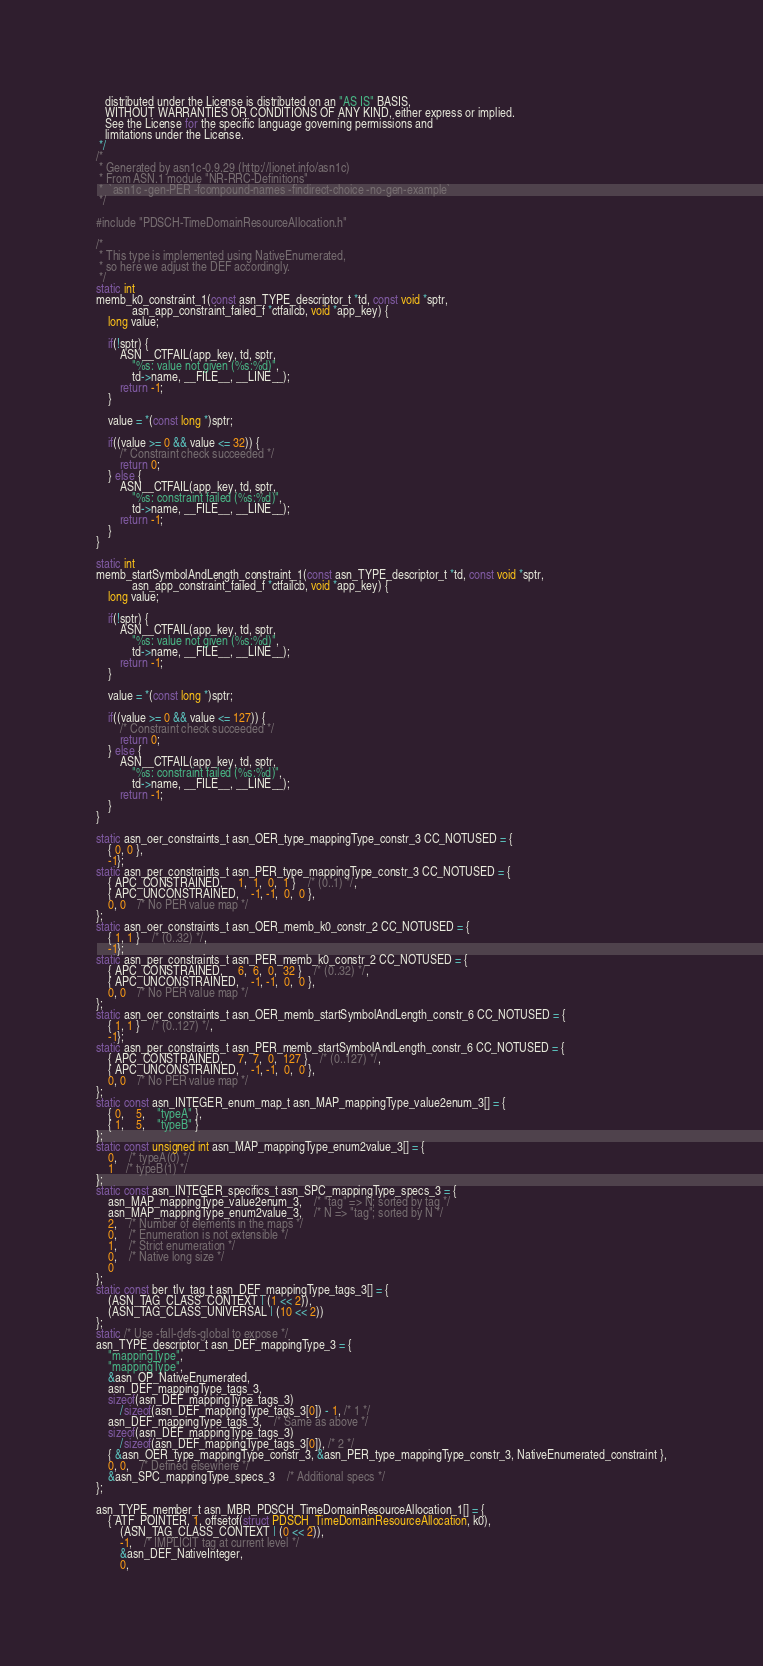<code> <loc_0><loc_0><loc_500><loc_500><_C_>   distributed under the License is distributed on an "AS IS" BASIS,
   WITHOUT WARRANTIES OR CONDITIONS OF ANY KIND, either express or implied.
   See the License for the specific language governing permissions and
   limitations under the License.
 */
/*
 * Generated by asn1c-0.9.29 (http://lionet.info/asn1c)
 * From ASN.1 module "NR-RRC-Definitions"
 * 	`asn1c -gen-PER -fcompound-names -findirect-choice -no-gen-example`
 */

#include "PDSCH-TimeDomainResourceAllocation.h"

/*
 * This type is implemented using NativeEnumerated,
 * so here we adjust the DEF accordingly.
 */
static int
memb_k0_constraint_1(const asn_TYPE_descriptor_t *td, const void *sptr,
			asn_app_constraint_failed_f *ctfailcb, void *app_key) {
	long value;
	
	if(!sptr) {
		ASN__CTFAIL(app_key, td, sptr,
			"%s: value not given (%s:%d)",
			td->name, __FILE__, __LINE__);
		return -1;
	}
	
	value = *(const long *)sptr;
	
	if((value >= 0 && value <= 32)) {
		/* Constraint check succeeded */
		return 0;
	} else {
		ASN__CTFAIL(app_key, td, sptr,
			"%s: constraint failed (%s:%d)",
			td->name, __FILE__, __LINE__);
		return -1;
	}
}

static int
memb_startSymbolAndLength_constraint_1(const asn_TYPE_descriptor_t *td, const void *sptr,
			asn_app_constraint_failed_f *ctfailcb, void *app_key) {
	long value;
	
	if(!sptr) {
		ASN__CTFAIL(app_key, td, sptr,
			"%s: value not given (%s:%d)",
			td->name, __FILE__, __LINE__);
		return -1;
	}
	
	value = *(const long *)sptr;
	
	if((value >= 0 && value <= 127)) {
		/* Constraint check succeeded */
		return 0;
	} else {
		ASN__CTFAIL(app_key, td, sptr,
			"%s: constraint failed (%s:%d)",
			td->name, __FILE__, __LINE__);
		return -1;
	}
}

static asn_oer_constraints_t asn_OER_type_mappingType_constr_3 CC_NOTUSED = {
	{ 0, 0 },
	-1};
static asn_per_constraints_t asn_PER_type_mappingType_constr_3 CC_NOTUSED = {
	{ APC_CONSTRAINED,	 1,  1,  0,  1 }	/* (0..1) */,
	{ APC_UNCONSTRAINED,	-1, -1,  0,  0 },
	0, 0	/* No PER value map */
};
static asn_oer_constraints_t asn_OER_memb_k0_constr_2 CC_NOTUSED = {
	{ 1, 1 }	/* (0..32) */,
	-1};
static asn_per_constraints_t asn_PER_memb_k0_constr_2 CC_NOTUSED = {
	{ APC_CONSTRAINED,	 6,  6,  0,  32 }	/* (0..32) */,
	{ APC_UNCONSTRAINED,	-1, -1,  0,  0 },
	0, 0	/* No PER value map */
};
static asn_oer_constraints_t asn_OER_memb_startSymbolAndLength_constr_6 CC_NOTUSED = {
	{ 1, 1 }	/* (0..127) */,
	-1};
static asn_per_constraints_t asn_PER_memb_startSymbolAndLength_constr_6 CC_NOTUSED = {
	{ APC_CONSTRAINED,	 7,  7,  0,  127 }	/* (0..127) */,
	{ APC_UNCONSTRAINED,	-1, -1,  0,  0 },
	0, 0	/* No PER value map */
};
static const asn_INTEGER_enum_map_t asn_MAP_mappingType_value2enum_3[] = {
	{ 0,	5,	"typeA" },
	{ 1,	5,	"typeB" }
};
static const unsigned int asn_MAP_mappingType_enum2value_3[] = {
	0,	/* typeA(0) */
	1	/* typeB(1) */
};
static const asn_INTEGER_specifics_t asn_SPC_mappingType_specs_3 = {
	asn_MAP_mappingType_value2enum_3,	/* "tag" => N; sorted by tag */
	asn_MAP_mappingType_enum2value_3,	/* N => "tag"; sorted by N */
	2,	/* Number of elements in the maps */
	0,	/* Enumeration is not extensible */
	1,	/* Strict enumeration */
	0,	/* Native long size */
	0
};
static const ber_tlv_tag_t asn_DEF_mappingType_tags_3[] = {
	(ASN_TAG_CLASS_CONTEXT | (1 << 2)),
	(ASN_TAG_CLASS_UNIVERSAL | (10 << 2))
};
static /* Use -fall-defs-global to expose */
asn_TYPE_descriptor_t asn_DEF_mappingType_3 = {
	"mappingType",
	"mappingType",
	&asn_OP_NativeEnumerated,
	asn_DEF_mappingType_tags_3,
	sizeof(asn_DEF_mappingType_tags_3)
		/sizeof(asn_DEF_mappingType_tags_3[0]) - 1, /* 1 */
	asn_DEF_mappingType_tags_3,	/* Same as above */
	sizeof(asn_DEF_mappingType_tags_3)
		/sizeof(asn_DEF_mappingType_tags_3[0]), /* 2 */
	{ &asn_OER_type_mappingType_constr_3, &asn_PER_type_mappingType_constr_3, NativeEnumerated_constraint },
	0, 0,	/* Defined elsewhere */
	&asn_SPC_mappingType_specs_3	/* Additional specs */
};

asn_TYPE_member_t asn_MBR_PDSCH_TimeDomainResourceAllocation_1[] = {
	{ ATF_POINTER, 1, offsetof(struct PDSCH_TimeDomainResourceAllocation, k0),
		(ASN_TAG_CLASS_CONTEXT | (0 << 2)),
		-1,	/* IMPLICIT tag at current level */
		&asn_DEF_NativeInteger,
		0,</code> 